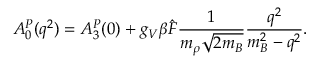Convert formula to latex. <formula><loc_0><loc_0><loc_500><loc_500>A _ { 0 } ^ { P } ( q ^ { 2 } ) = A _ { 3 } ^ { P } ( 0 ) + g _ { V } \beta { \hat { F } } \frac { 1 } { m _ { \rho } \sqrt { 2 m _ { B } } } \frac { q ^ { 2 } } { m _ { B } ^ { 2 } - q ^ { 2 } } .</formula> 